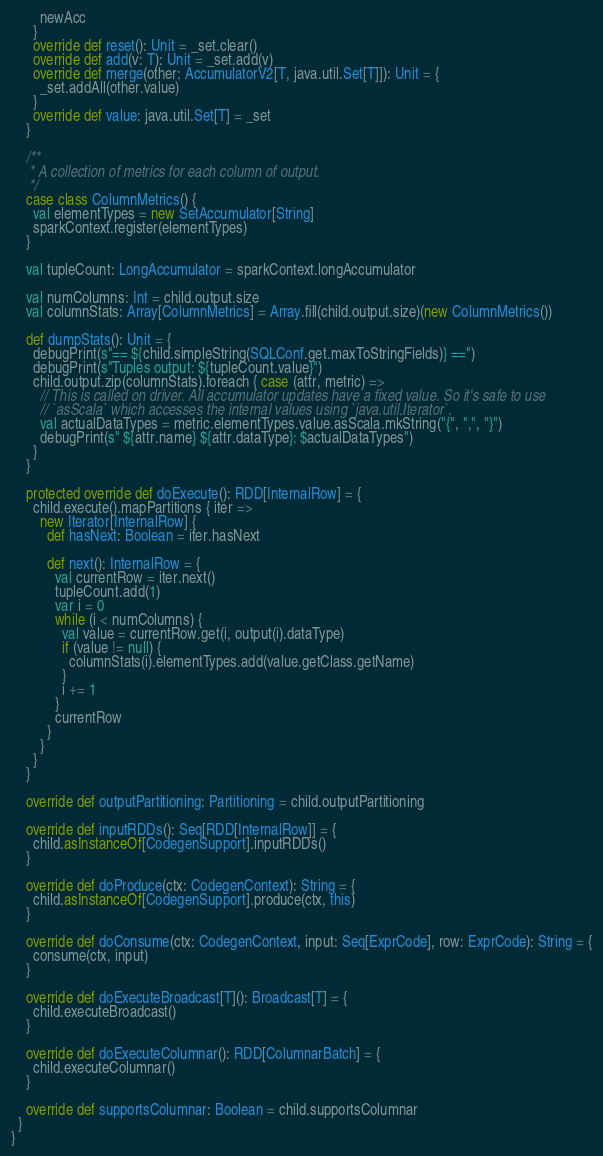<code> <loc_0><loc_0><loc_500><loc_500><_Scala_>        newAcc
      }
      override def reset(): Unit = _set.clear()
      override def add(v: T): Unit = _set.add(v)
      override def merge(other: AccumulatorV2[T, java.util.Set[T]]): Unit = {
        _set.addAll(other.value)
      }
      override def value: java.util.Set[T] = _set
    }

    /**
     * A collection of metrics for each column of output.
     */
    case class ColumnMetrics() {
      val elementTypes = new SetAccumulator[String]
      sparkContext.register(elementTypes)
    }

    val tupleCount: LongAccumulator = sparkContext.longAccumulator

    val numColumns: Int = child.output.size
    val columnStats: Array[ColumnMetrics] = Array.fill(child.output.size)(new ColumnMetrics())

    def dumpStats(): Unit = {
      debugPrint(s"== ${child.simpleString(SQLConf.get.maxToStringFields)} ==")
      debugPrint(s"Tuples output: ${tupleCount.value}")
      child.output.zip(columnStats).foreach { case (attr, metric) =>
        // This is called on driver. All accumulator updates have a fixed value. So it's safe to use
        // `asScala` which accesses the internal values using `java.util.Iterator`.
        val actualDataTypes = metric.elementTypes.value.asScala.mkString("{", ",", "}")
        debugPrint(s" ${attr.name} ${attr.dataType}: $actualDataTypes")
      }
    }

    protected override def doExecute(): RDD[InternalRow] = {
      child.execute().mapPartitions { iter =>
        new Iterator[InternalRow] {
          def hasNext: Boolean = iter.hasNext

          def next(): InternalRow = {
            val currentRow = iter.next()
            tupleCount.add(1)
            var i = 0
            while (i < numColumns) {
              val value = currentRow.get(i, output(i).dataType)
              if (value != null) {
                columnStats(i).elementTypes.add(value.getClass.getName)
              }
              i += 1
            }
            currentRow
          }
        }
      }
    }

    override def outputPartitioning: Partitioning = child.outputPartitioning

    override def inputRDDs(): Seq[RDD[InternalRow]] = {
      child.asInstanceOf[CodegenSupport].inputRDDs()
    }

    override def doProduce(ctx: CodegenContext): String = {
      child.asInstanceOf[CodegenSupport].produce(ctx, this)
    }

    override def doConsume(ctx: CodegenContext, input: Seq[ExprCode], row: ExprCode): String = {
      consume(ctx, input)
    }

    override def doExecuteBroadcast[T](): Broadcast[T] = {
      child.executeBroadcast()
    }

    override def doExecuteColumnar(): RDD[ColumnarBatch] = {
      child.executeColumnar()
    }

    override def supportsColumnar: Boolean = child.supportsColumnar
  }
}
</code> 